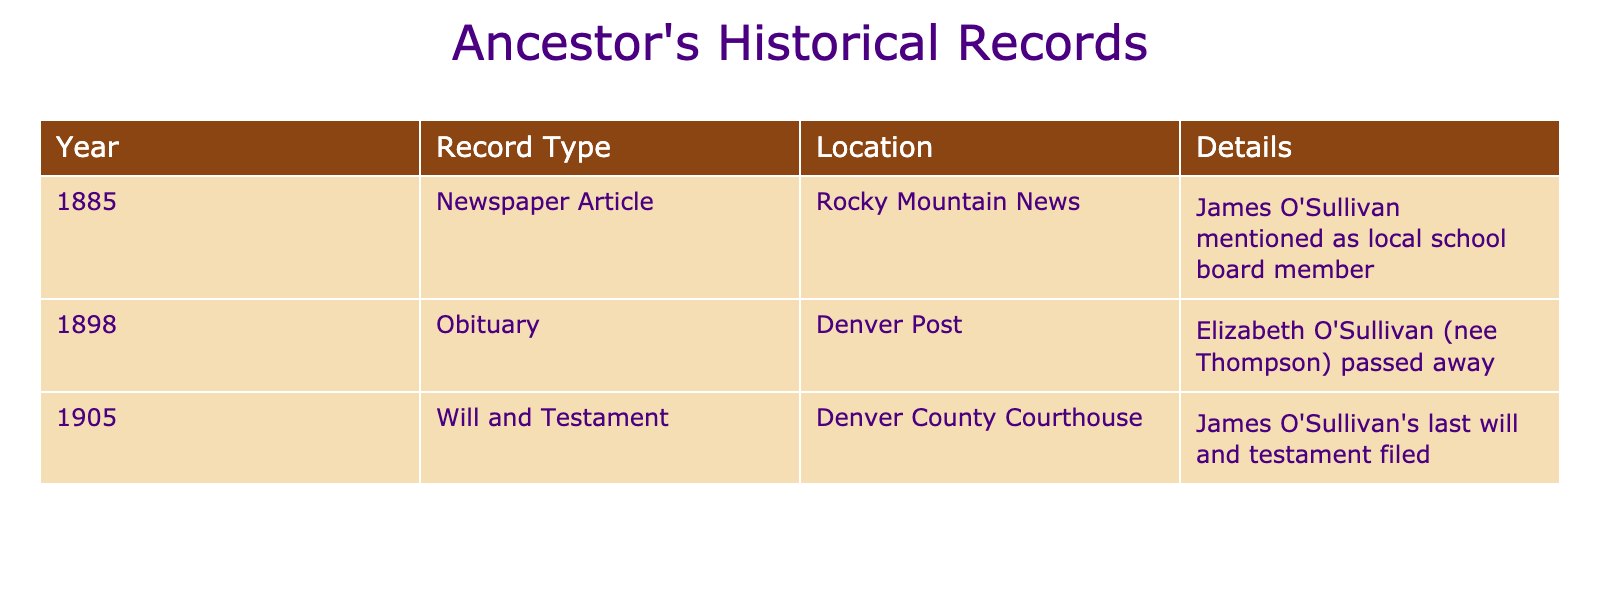What year was James O'Sullivan mentioned in a newspaper article? The table lists instances of the ancestor's name appearing in historical records. For James O'Sullivan, the newspaper article entry states "1885" in the Year column.
Answer: 1885 What type of record details Elizabeth O'Sullivan's passing? By looking at the record type related to Elizabeth O'Sullivan, the table indicates "Obituary" in the Record Type column for the year 1898.
Answer: Obituary In which location was James O'Sullivan's will and testament filed? Referring to the details related to James O'Sullivan, the table specifies "Denver County Courthouse" in the Location column for the record type of Will and Testament in the year 1905.
Answer: Denver County Courthouse How many years apart were Elizabeth O'Sullivan's obituary and James O'Sullivan's will and testament filed? To find the difference, identify the years of the two records: Elizabeth O'Sullivan passed away in 1898 and James O'Sullivan's will was filed in 1905. The difference is 1905 - 1898 = 7 years.
Answer: 7 years Did James O'Sullivan appear in the records before Elizabeth O'Sullivan? The table shows that James O'Sullivan was mentioned in 1885 and Elizabeth O'Sullivan in 1898. Since 1885 is earlier than 1898, the answer is yes.
Answer: Yes What is the total number of records listed for James O'Sullivan? Looking at the table, there are two records explicitly mentioning James O'Sullivan: one in the newspaper article from 1885 and one will and testament from 1905. Therefore, the total is 2 records.
Answer: 2 Which record type was documented in the year 1905? The table indicates that 1905 is associated with the record type "Will and Testament" for James O'Sullivan in the Record Type column.
Answer: Will and Testament How many different record types are mentioned in the table? The table details three record types: Newspaper Article, Obituary, and Will and Testament. Counting these, there are three distinct record types.
Answer: 3 Was there any record of Elizabeth O'Sullivan before 1900? The table shows Elizabeth O'Sullivan's obituary in 1898, which is indeed before 1900, therefore confirming that there is a record of her before that year.
Answer: Yes What specific detail is mentioned in the newspaper article about James O'Sullivan? Referring to the table, the detail states that James O'Sullivan was mentioned as a local school board member in the newspaper article in 1885.
Answer: Local school board member 